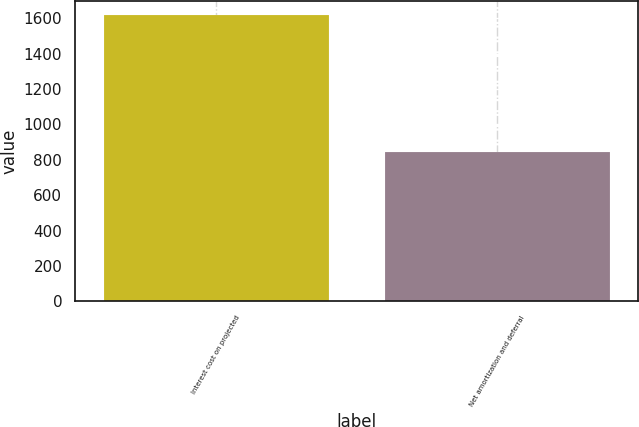Convert chart. <chart><loc_0><loc_0><loc_500><loc_500><bar_chart><fcel>Interest cost on projected<fcel>Net amortization and deferral<nl><fcel>1617<fcel>841<nl></chart> 